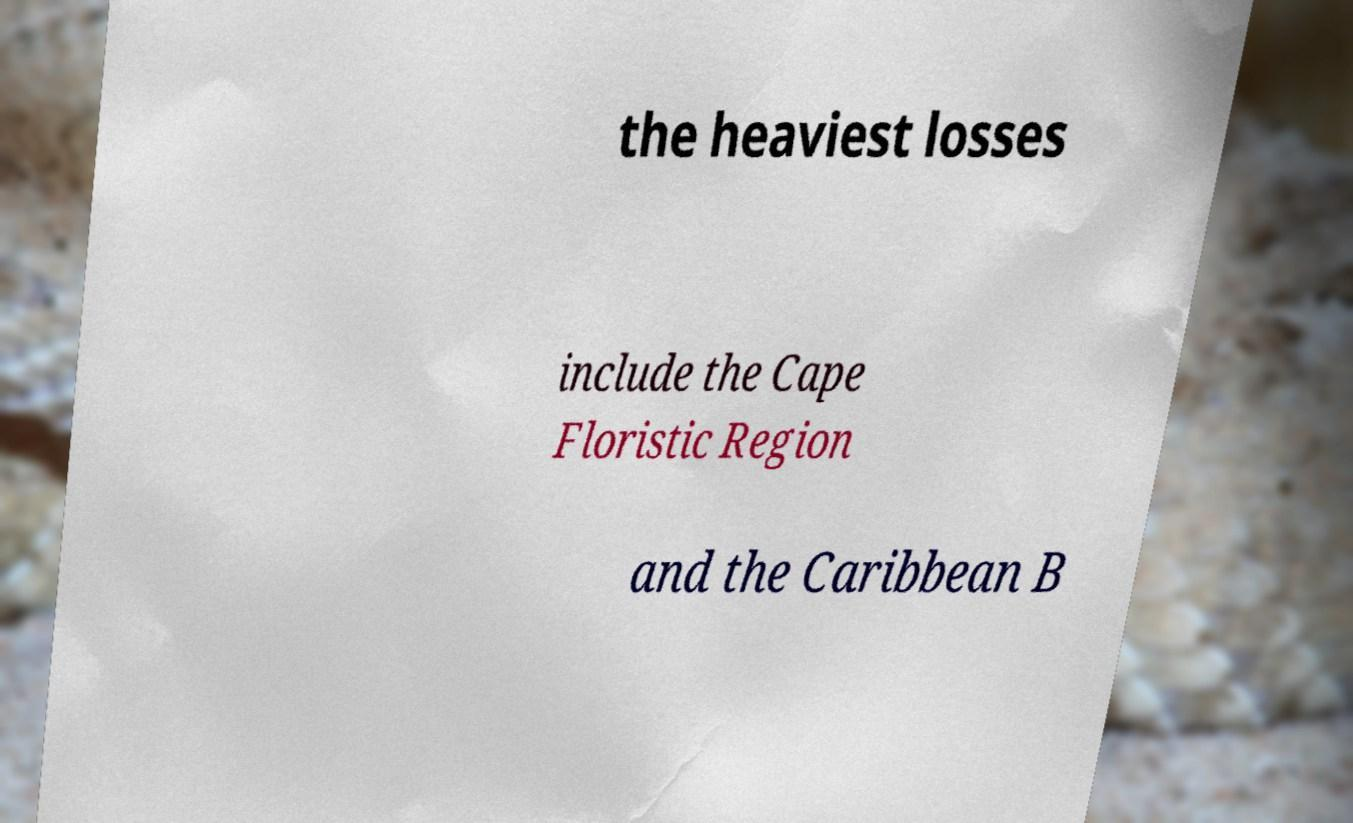Could you extract and type out the text from this image? the heaviest losses include the Cape Floristic Region and the Caribbean B 